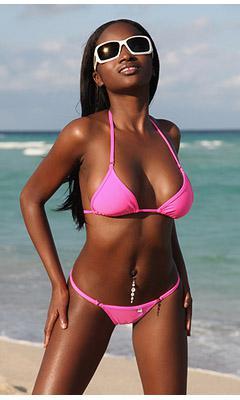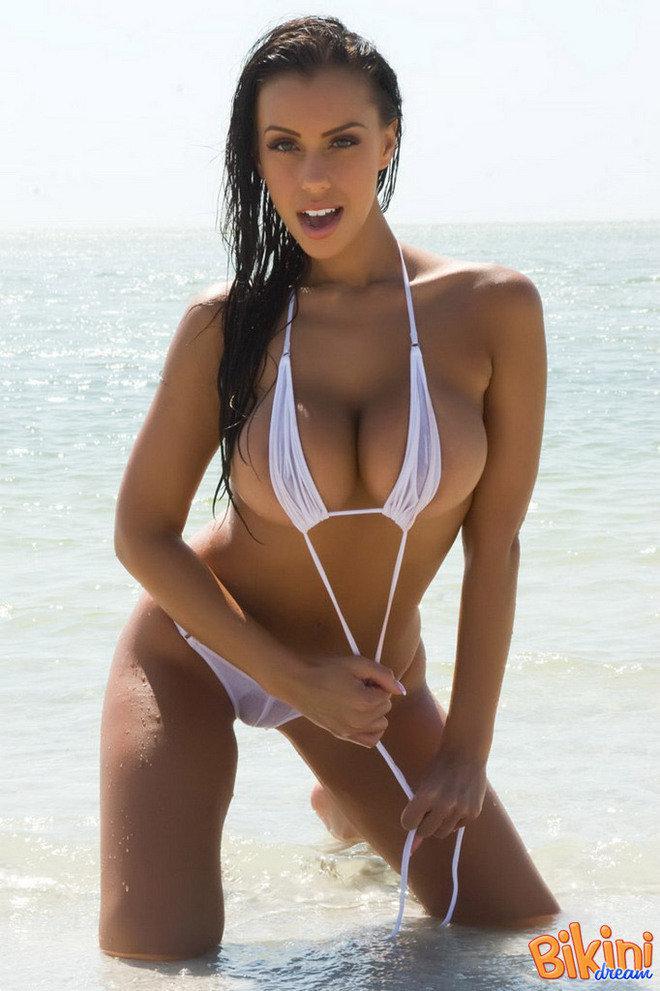The first image is the image on the left, the second image is the image on the right. For the images shown, is this caption "The bikini belonging to the woman on the left is only one color: white." true? Answer yes or no. No. The first image is the image on the left, the second image is the image on the right. Given the left and right images, does the statement "Each image shows a bikini model standing with the hand on the right lifted to her hair, but only one of the models has her other arm bent at the elbow with a hand above her hip." hold true? Answer yes or no. No. 